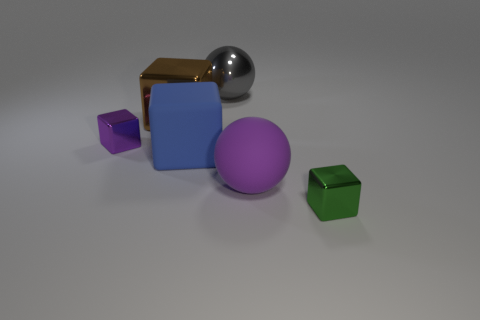Does the small green object have the same material as the gray ball to the left of the large purple matte ball?
Provide a succinct answer. Yes. Is the shape of the tiny green metal object the same as the large gray object?
Keep it short and to the point. No. There is another large object that is the same shape as the large gray thing; what material is it?
Provide a short and direct response. Rubber. The big object that is in front of the big shiny ball and behind the large blue matte cube is what color?
Make the answer very short. Brown. The big metallic block is what color?
Offer a terse response. Brown. What is the material of the small cube that is the same color as the big rubber ball?
Ensure brevity in your answer.  Metal. Is there another brown metal thing of the same shape as the brown thing?
Offer a terse response. No. There is a shiny object that is in front of the small purple thing; what size is it?
Your answer should be very brief. Small. What material is the cube that is the same size as the purple metal object?
Your answer should be very brief. Metal. Is the number of large blue objects greater than the number of brown rubber things?
Ensure brevity in your answer.  Yes. 